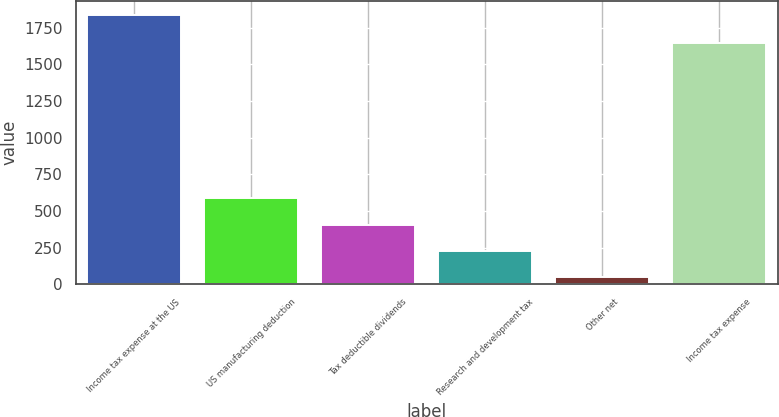Convert chart. <chart><loc_0><loc_0><loc_500><loc_500><bar_chart><fcel>Income tax expense at the US<fcel>US manufacturing deduction<fcel>Tax deductible dividends<fcel>Research and development tax<fcel>Other net<fcel>Income tax expense<nl><fcel>1840<fcel>586.3<fcel>407.2<fcel>228.1<fcel>49<fcel>1644<nl></chart> 